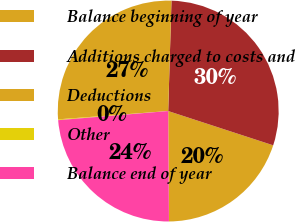Convert chart to OTSL. <chart><loc_0><loc_0><loc_500><loc_500><pie_chart><fcel>Balance beginning of year<fcel>Additions charged to costs and<fcel>Deductions<fcel>Other<fcel>Balance end of year<nl><fcel>19.87%<fcel>29.55%<fcel>26.67%<fcel>0.12%<fcel>23.79%<nl></chart> 